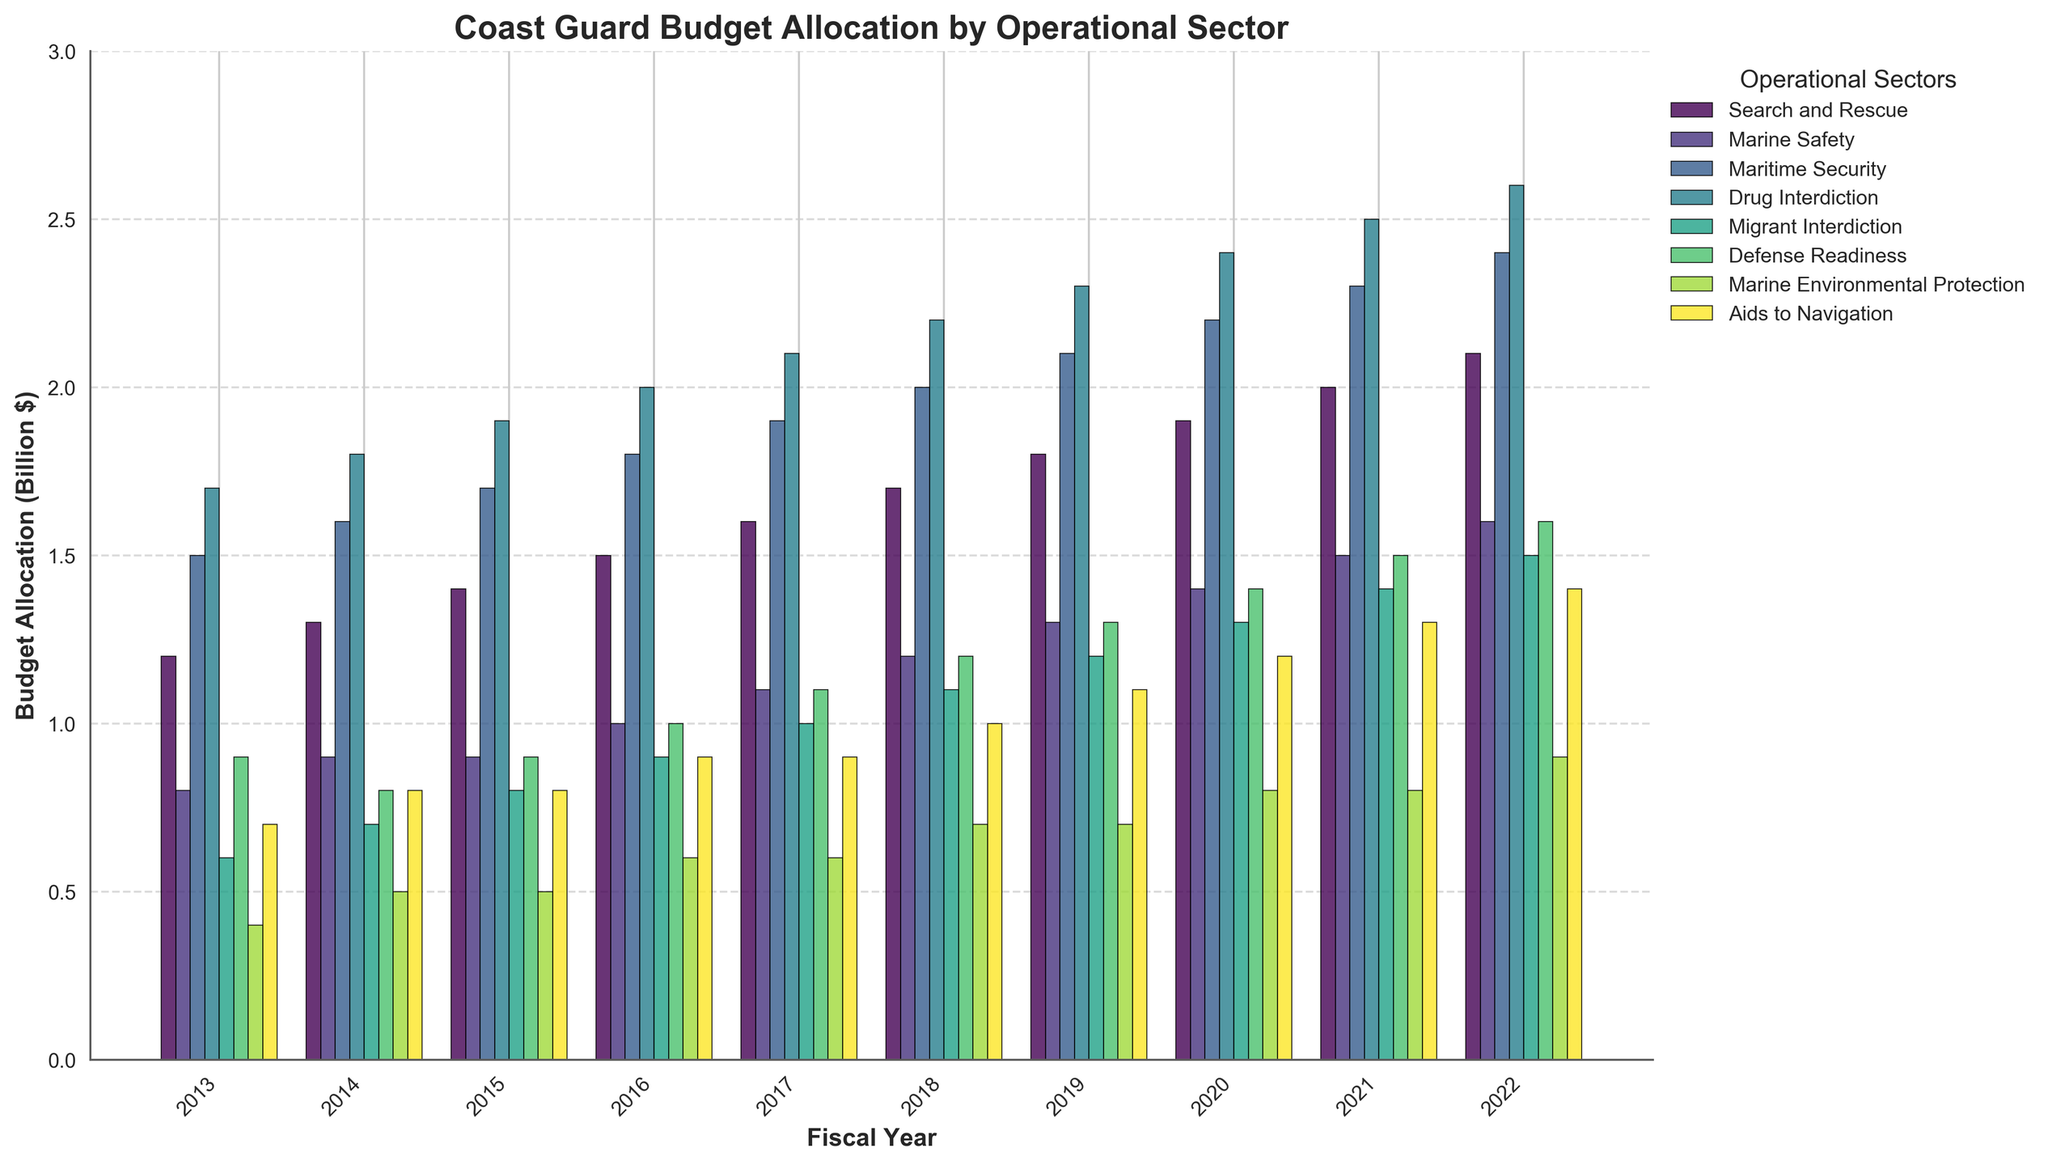What's the overall trend of the budget allocation for Drug Interdiction from 2013 to 2022? Observe the height of the bars for Drug Interdiction from 2013 to 2022. The height of the bars increases steadily each year, indicating an increasing budget allocation.
Answer: Increasing trend Which operational sector had the highest budget allocation in 2022 and what was its value? Find the tallest bar in the 2022 section. The Maritime Security bar is the highest, with a budget allocation of 2.6 billion dollars.
Answer: Maritime Security, 2.6 billion dollars Sum the budget allocations for Search and Rescue and Marine Safety in 2021. Locate the bars for Search and Rescue and Marine Safety in 2021. Sum their heights: 2.0 (Search and Rescue) + 1.5 (Marine Safety) = 3.5 billion dollars.
Answer: 3.5 billion dollars Which sector had the lowest budget allocation in 2013 and what was the value? Identify the shortest bar in the 2013 section. The Marine Environmental Protection bar is the shortest, with a budget allocation of 0.4 billion dollars.
Answer: Marine Environmental Protection, 0.4 billion dollars Compare the budget allocation for Defense Readiness in 2016 to that in 2019. Which year had a higher allocation and by how much? Look at the bars for Defense Readiness in 2016 and 2019. The bar in 2019 is higher at 1.3 billion dollars compared to 2016 at 1.0 billion dollars. The difference is 1.3 - 1.0 = 0.3 billion dollars.
Answer: 2019, by 0.3 billion dollars What was the average budget allocation for Aids to Navigation across the decade? Sum the Aids to Navigation allocations from 2013 to 2022 and divide by 10: (0.7 + 0.8 + 0.8 + 0.9 + 0.9 + 1.0 + 1.1 + 1.2 + 1.3 + 1.4) / 10 = 9.1 / 10 = 0.91 billion dollars.
Answer: 0.91 billion dollars By how much did the budget allocation for Maritime Security increase from 2013 to 2022? Calculate the difference in Maritime Security budget between 2013 and 2022: 2.4 - 1.5 = 0.9 billion dollars.
Answer: 0.9 billion dollars Identify an operational sector whose budget allocation has consistently increased every year from 2013 to 2022. Inspect the bars of each sector from 2013 to 2022 to see if any sector's allocation consistently increased each year. The Maritime Security sector shows a consistent increase.
Answer: Maritime Security What is the difference in budget allocation between Drug Interdiction and Migrant Interdiction in 2020? Subtract the Migrant Interdiction budget from the Drug Interdiction budget for 2020. The values are 2.4 (Drug Interdiction) - 1.3 (Migrant Interdiction) = 1.1 billion dollars.
Answer: 1.1 billion dollars In what year did the Search and Rescue budget allocation first reach 2 billion dollars? Find the year where the Search and Rescue bar first reaches or exceeds the 2 billion dollar mark. This happens in 2021.
Answer: 2021 